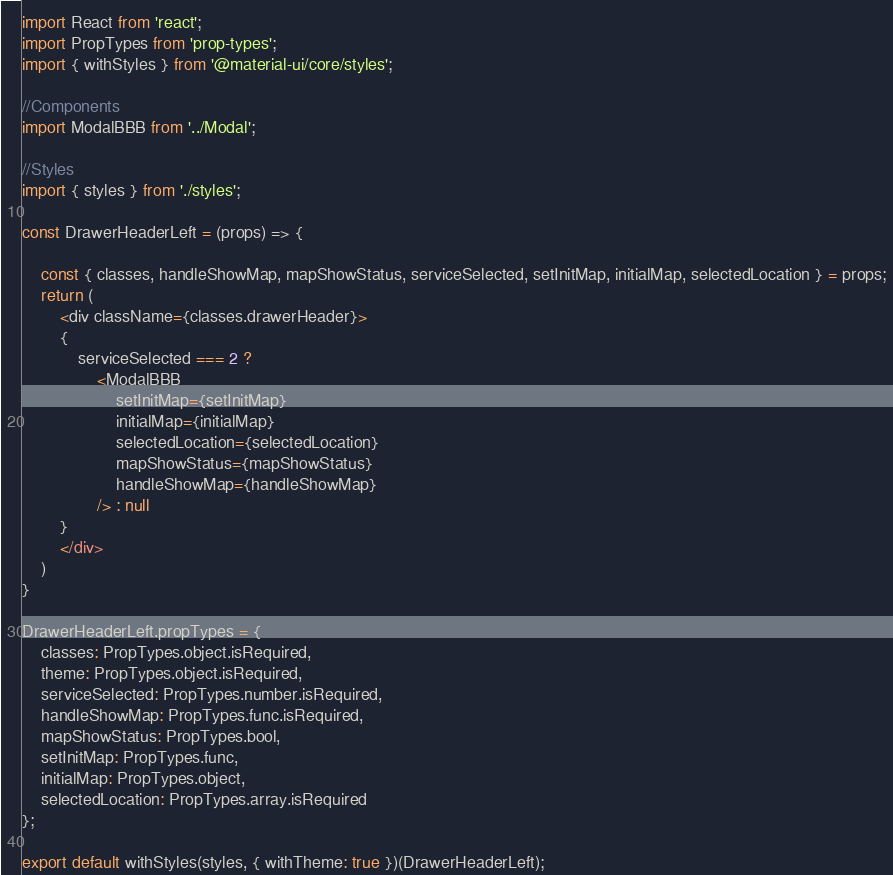Convert code to text. <code><loc_0><loc_0><loc_500><loc_500><_JavaScript_>import React from 'react';
import PropTypes from 'prop-types';
import { withStyles } from '@material-ui/core/styles';

//Components
import ModalBBB from '../Modal';

//Styles
import { styles } from './styles';

const DrawerHeaderLeft = (props) => {

    const { classes, handleShowMap, mapShowStatus, serviceSelected, setInitMap, initialMap, selectedLocation } = props;
    return (
        <div className={classes.drawerHeader}>
        {
            serviceSelected === 2 ?
                <ModalBBB 
                    setInitMap={setInitMap}
                    initialMap={initialMap}
                    selectedLocation={selectedLocation}
                    mapShowStatus={mapShowStatus} 
                    handleShowMap={handleShowMap}
                /> : null
        }
        </div>
    )
}

DrawerHeaderLeft.propTypes = {
    classes: PropTypes.object.isRequired,
    theme: PropTypes.object.isRequired,
    serviceSelected: PropTypes.number.isRequired,
    handleShowMap: PropTypes.func.isRequired,
    mapShowStatus: PropTypes.bool,
    setInitMap: PropTypes.func,
    initialMap: PropTypes.object,
    selectedLocation: PropTypes.array.isRequired
};

export default withStyles(styles, { withTheme: true })(DrawerHeaderLeft);</code> 